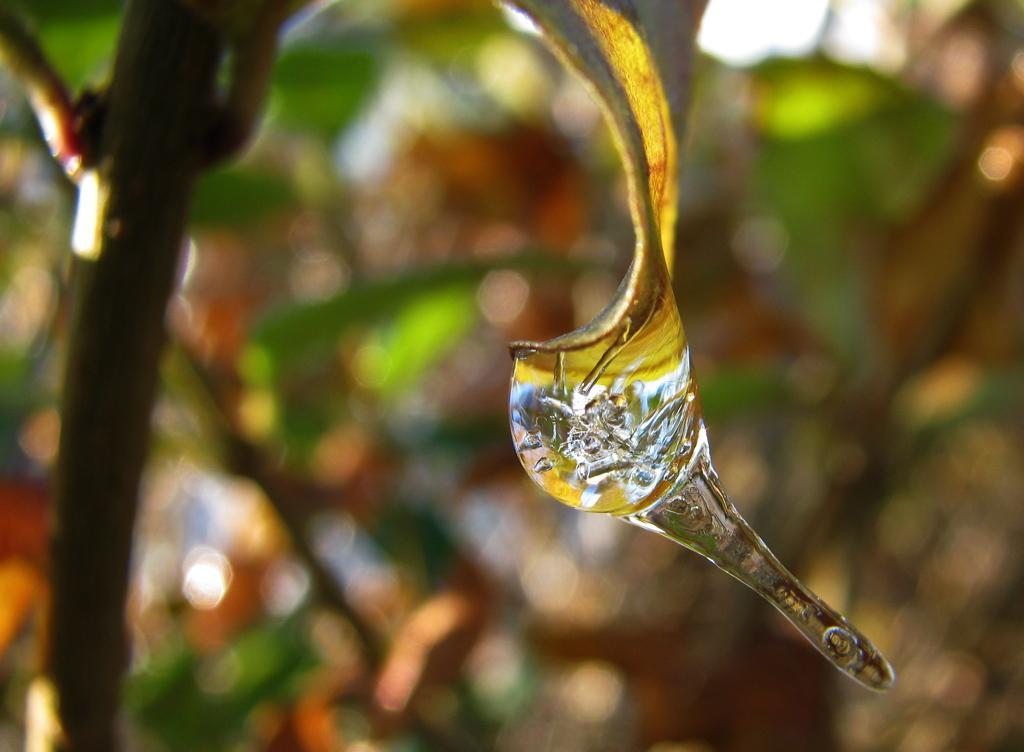How would you summarize this image in a sentence or two? In this image we can see a water drop on the leaf. The background of the image is blur. 